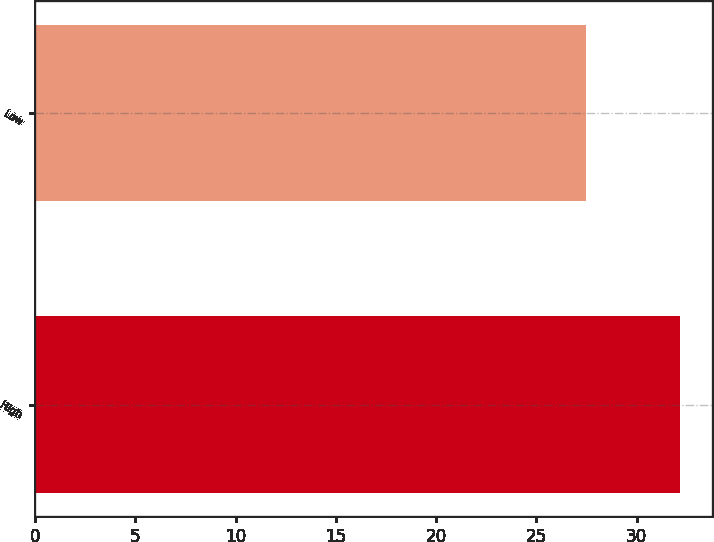Convert chart to OTSL. <chart><loc_0><loc_0><loc_500><loc_500><bar_chart><fcel>High<fcel>Low<nl><fcel>32.18<fcel>27.5<nl></chart> 